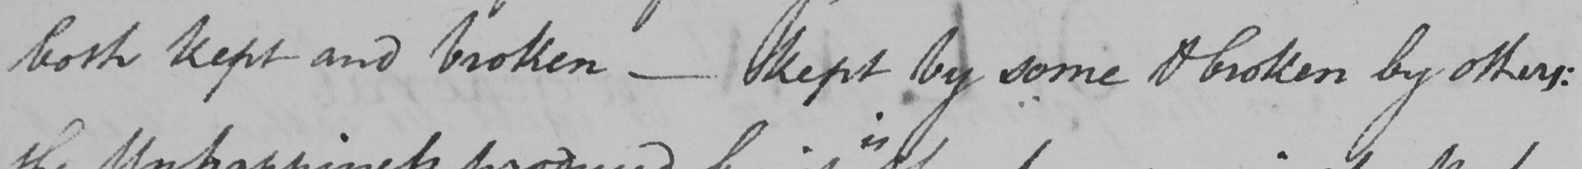Transcribe the text shown in this historical manuscript line. both kept and broken  _  kept by some & broken by others : 